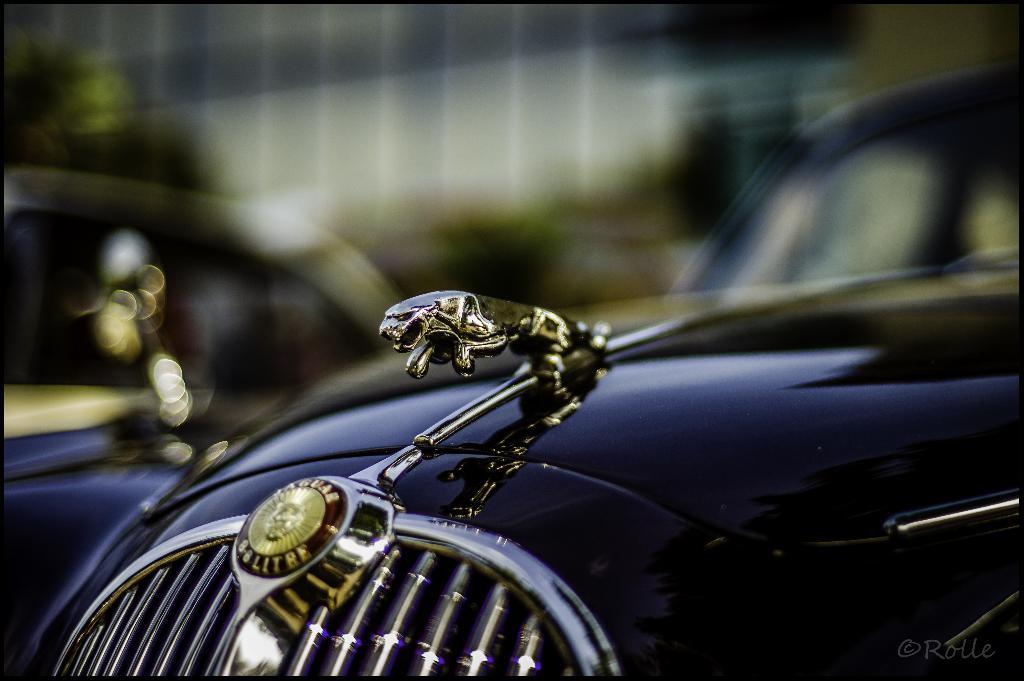What types of objects are present in the image? There are vehicles in the image. Can you describe any specific features of the vehicles? Yes, there is text visible on a vehicle, and there appears to be a sculpture on a vehicle. What can be seen in the background of the image? There is a building and trees visible in the background. What is the limit of the territory covered by the vehicles in the image? There is no information about the territory or its limits in the image; it only shows vehicles with text and a sculpture. 